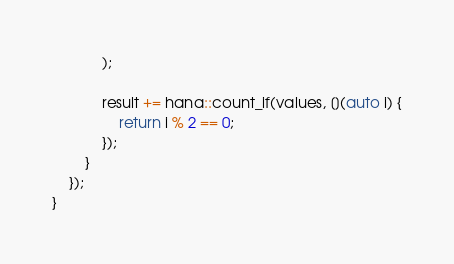<code> <loc_0><loc_0><loc_500><loc_500><_C++_>            );

            result += hana::count_if(values, [](auto i) {
                return i % 2 == 0;
            });
        }
    });
}
</code> 